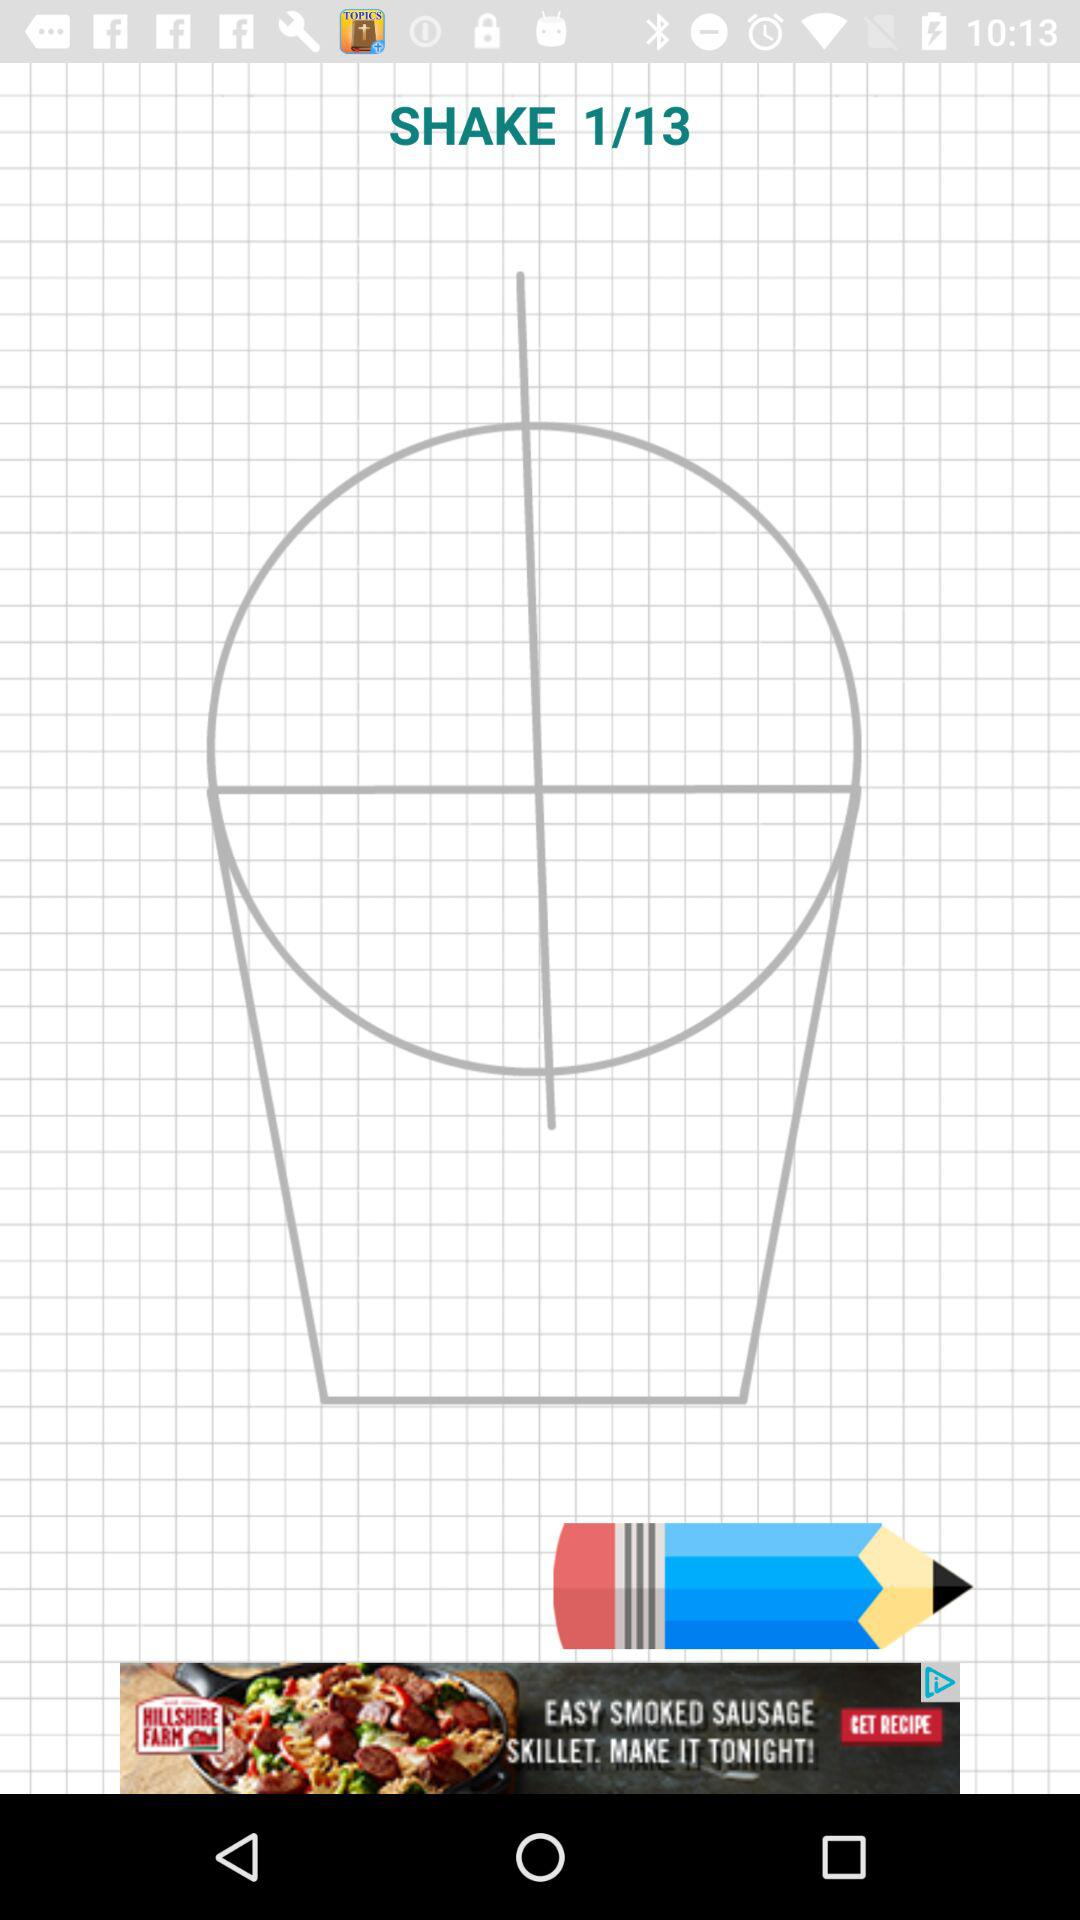How many total images are there? There are a total of 13 images. 